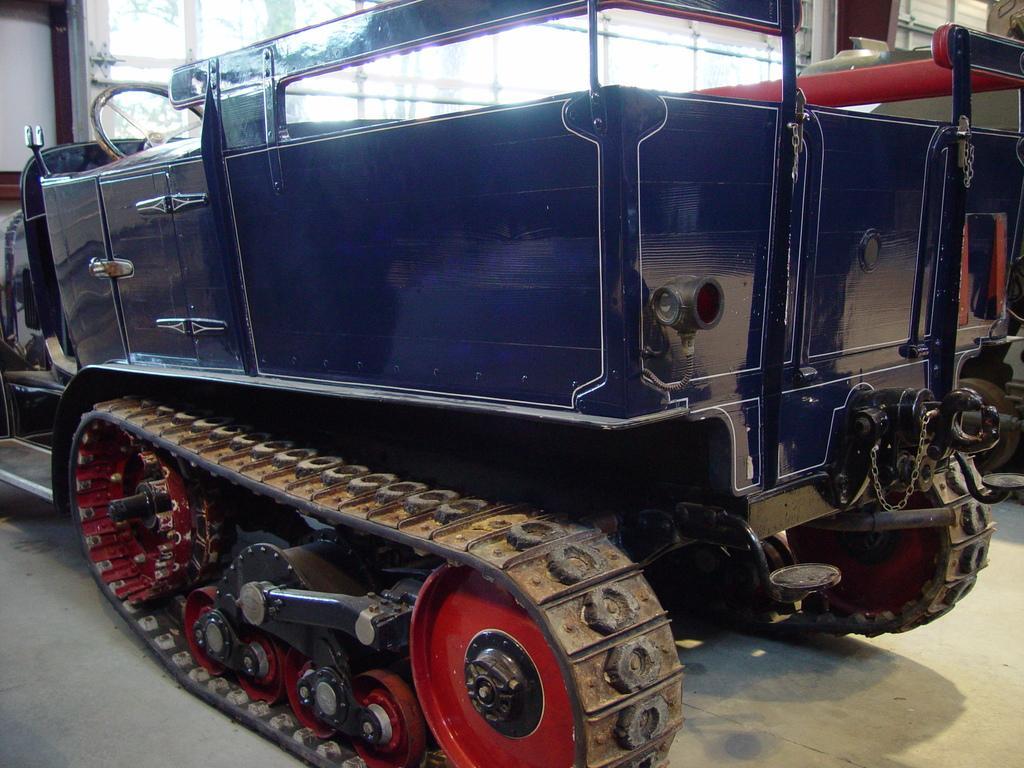Can you describe this image briefly? In this picture we can see an artillery tractor in the front, on the left side there is steering, in the background we can see glass. 